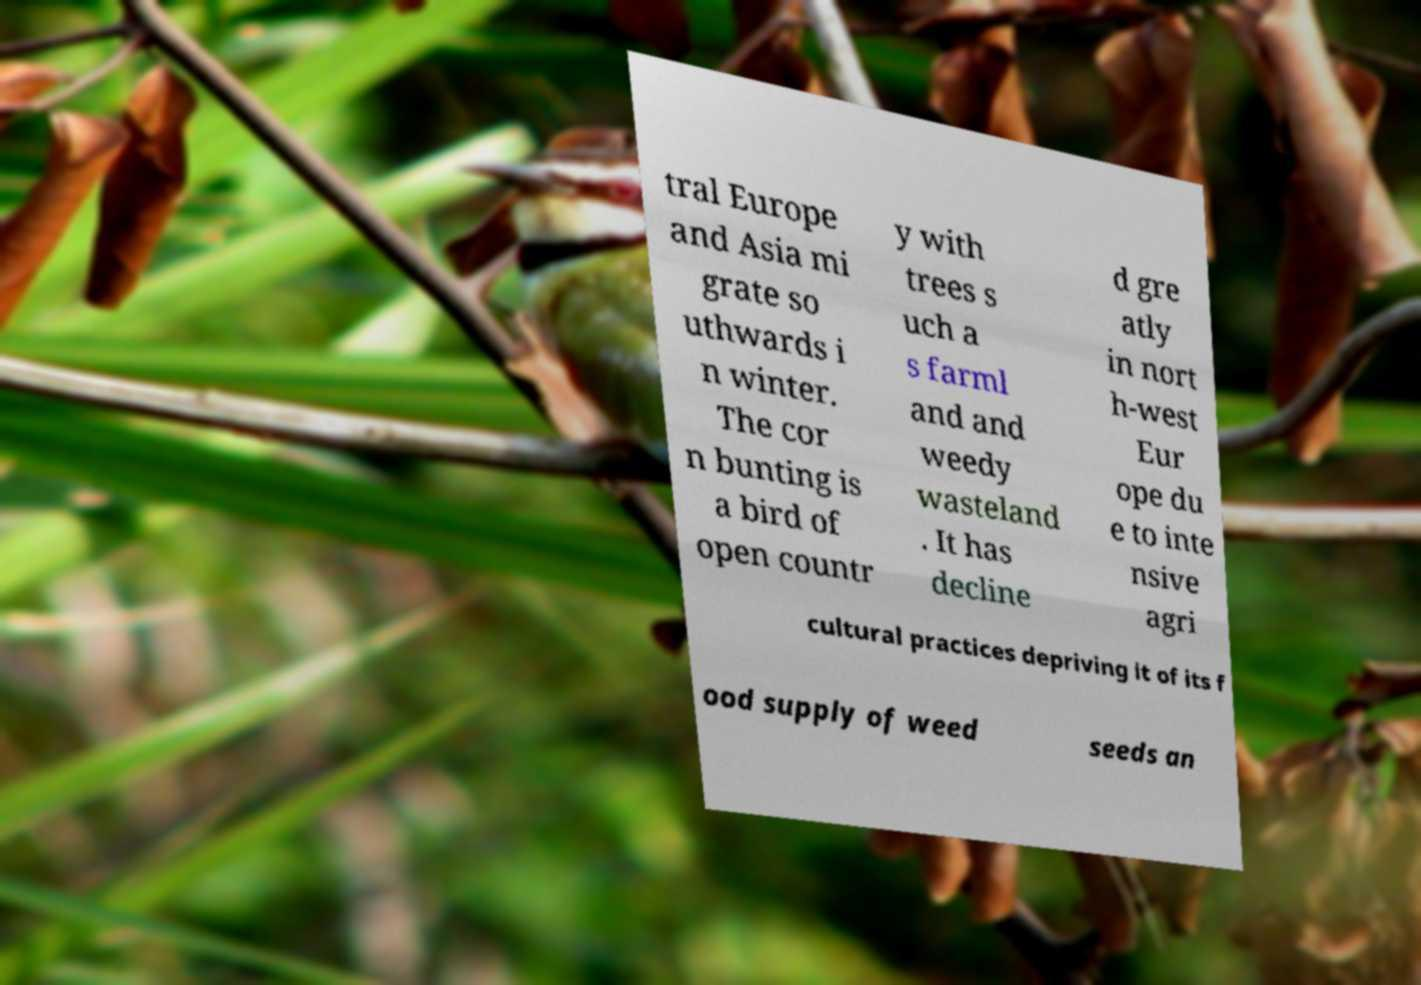Could you extract and type out the text from this image? tral Europe and Asia mi grate so uthwards i n winter. The cor n bunting is a bird of open countr y with trees s uch a s farml and and weedy wasteland . It has decline d gre atly in nort h-west Eur ope du e to inte nsive agri cultural practices depriving it of its f ood supply of weed seeds an 